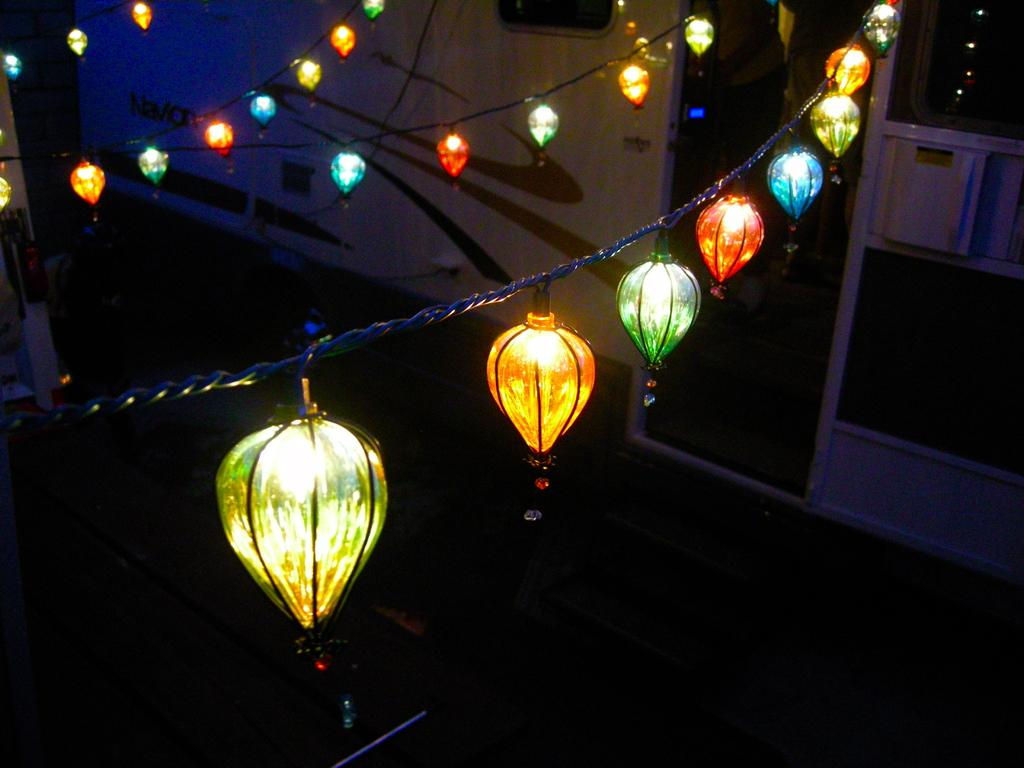What objects are visible in the image? There are ropes and decorative lights in the image. Can you describe the lights in more detail? The lights are decorative and are present on the ropes. What is located on the right side of the lights? There is a wall on the right side of the lights. What type of kite is being taught to fly in the image? There is no kite present in the image, and no teaching or flying activity is depicted. 